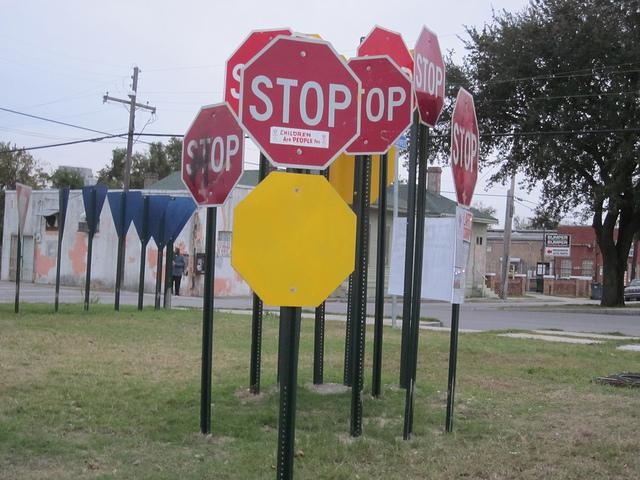What is the purpose of this signage? Please explain your reasoning. art display. This many traffic signs would not naturally be placed thus close together, so an art display is is reasonable assumption. 